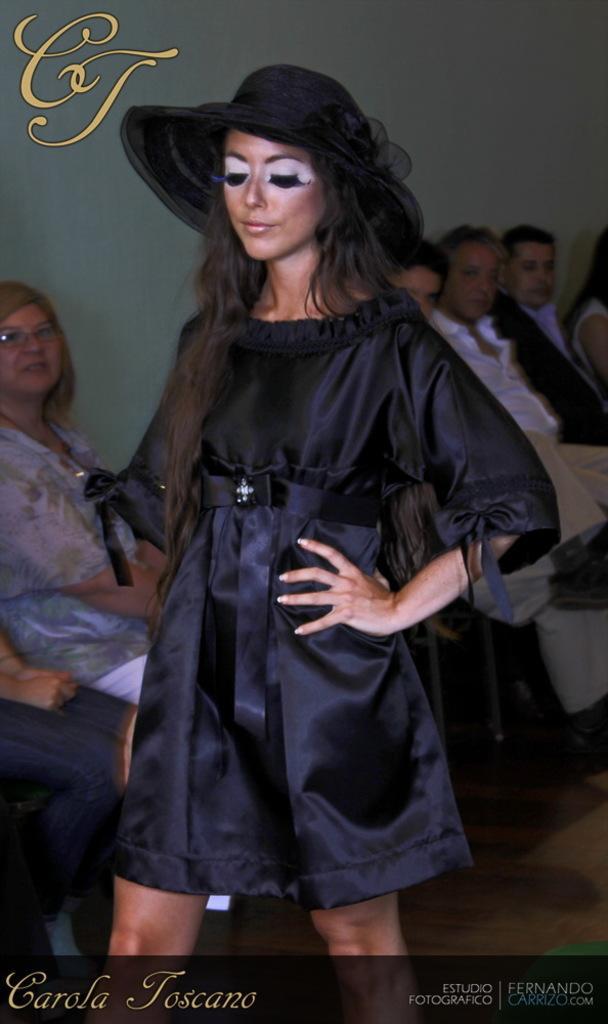How would you summarize this image in a sentence or two? In the foreground of this image, there is a woman wearing hat and black color dress. At the bottom, there is some text. In the background, there are people sitting near a wall. 